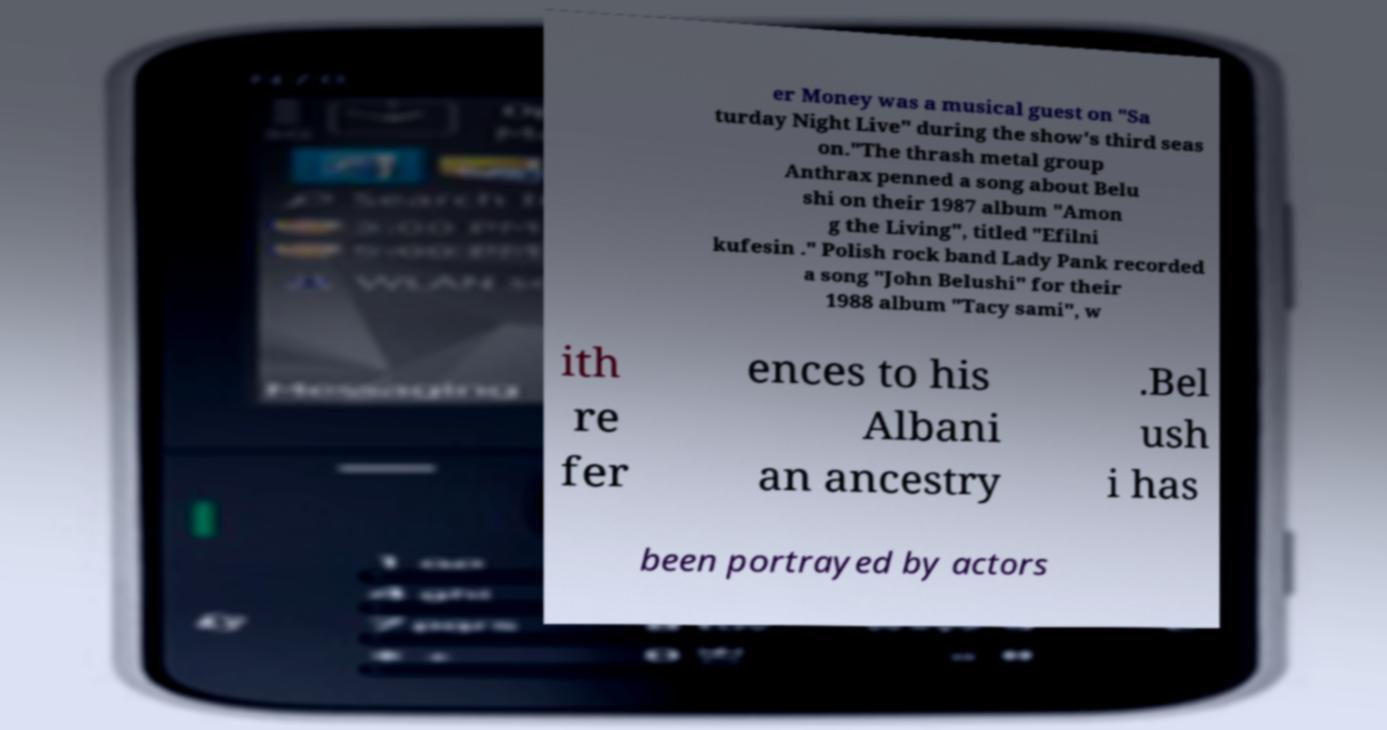Can you accurately transcribe the text from the provided image for me? er Money was a musical guest on "Sa turday Night Live" during the show's third seas on."The thrash metal group Anthrax penned a song about Belu shi on their 1987 album "Amon g the Living", titled "Efilni kufesin ." Polish rock band Lady Pank recorded a song "John Belushi" for their 1988 album "Tacy sami", w ith re fer ences to his Albani an ancestry .Bel ush i has been portrayed by actors 